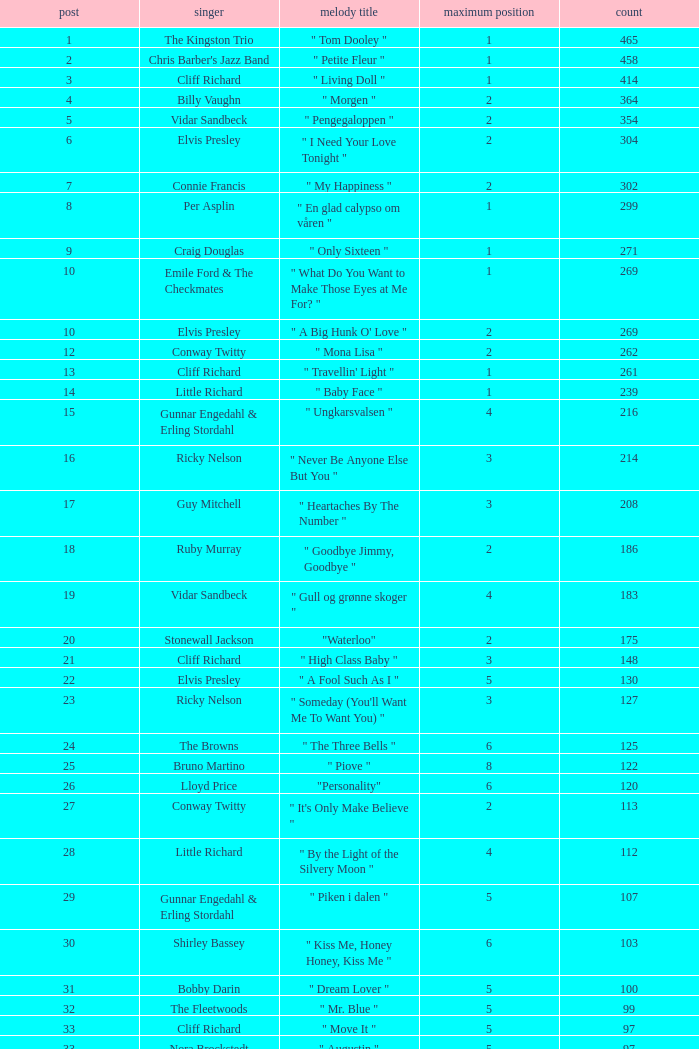What is the nme of the song performed by billy vaughn? " Morgen ". 